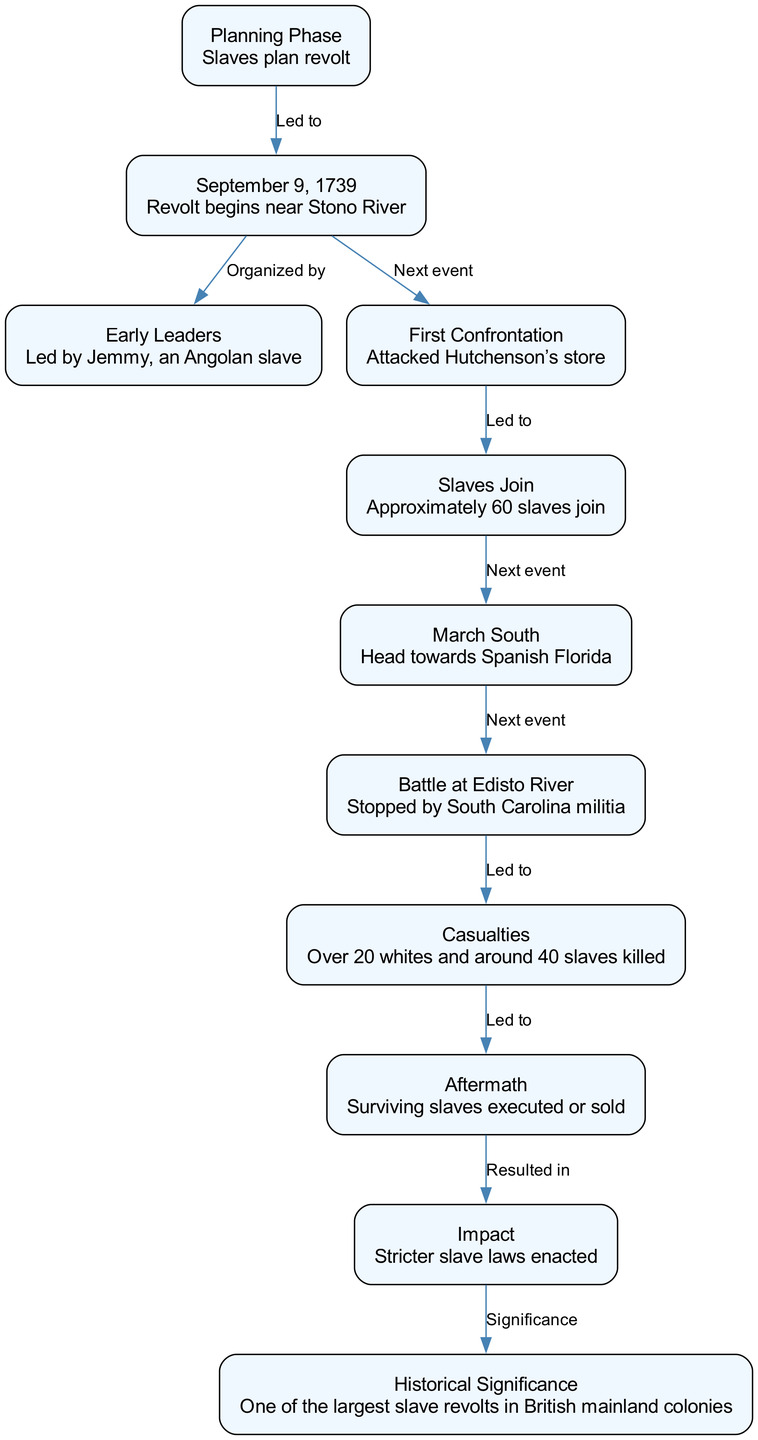What event initiated the Stono Rebellion timeline? The diagram identifies the event that initiated the timeline as the "Revolt begins near Stono River" occurring on "September 9, 1739." This is the first chronological event in the timeline.
Answer: Revolt begins near Stono River Who was the leader of the rebellion? According to the diagram, "Led by Jemmy, an Angolan slave" is indicated as the primary leadership during the rebellion. This information directly references the early leadership role identified in the timeline.
Answer: Jemmy What was the number of slaves that joined the rebellion? The diagram provides that approximately "60 slaves join" the revolt after the initial attack on Hutchenson's store. This number indicates the growth of the rebellion participants.
Answer: 60 slaves What outcome did the rebellion lead to? In the diagram, it is shown that "Surviving slaves executed or sold" represents the aftermath of the Stono Rebellion, highlighting the severe consequences for those involved.
Answer: Surviving slaves executed or sold What significant impact resulted from the Stono Rebellion? The diagram indicates that "Stricter slave laws enacted" is a significant impact that arose as a response to the rebellion. This suggests the lasting effects on policies regarding slavery in the region.
Answer: Stricter slave laws enacted How many total casualties were reported in the rebellion? The timeline notes "Over 20 whites and around 40 slaves killed." Combining these figures, the total number of casualties provides a sense of the conflict's severity, relating directly to the consequences of the confrontation.
Answer: 60 What was the relationship between the first confrontation and the joining of slaves? The diagram illustrates that the "Attacked Hutchenson’s store" led to "Approximately 60 slaves join." This indicates a direct cause-and-effect relationship where the attack prompted more slaves to join the revolt.
Answer: Led to What does the aftermath of the Stono Rebellion illustrate about the rebels? The diagram states that "Surviving slaves executed or sold" showcases the harsh repercussions faced by the rebels after the uprising, indicating the brutal response from authorities.
Answer: Harsh repercussions 